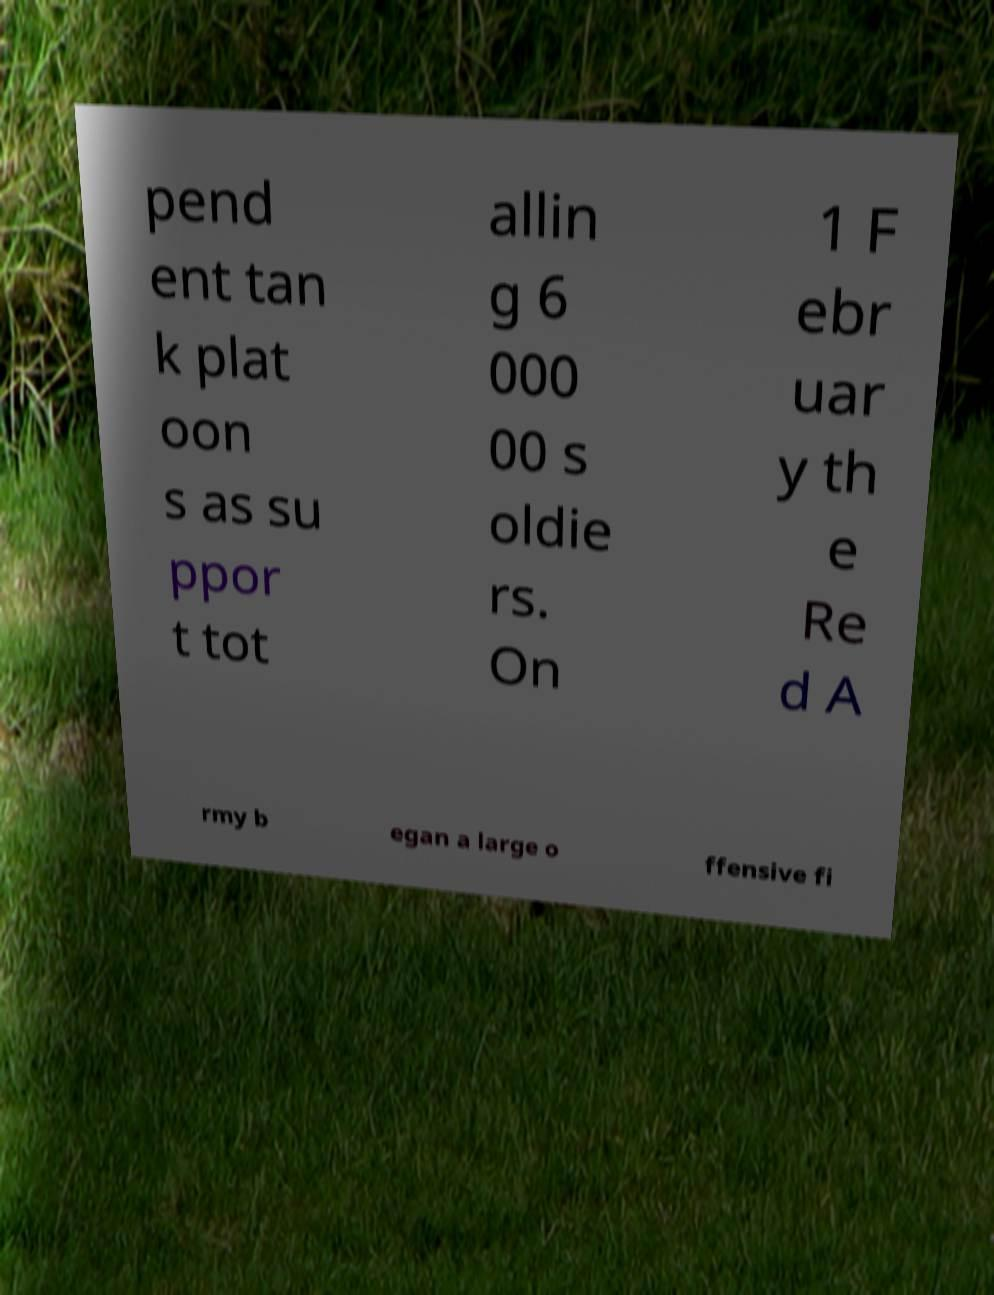For documentation purposes, I need the text within this image transcribed. Could you provide that? pend ent tan k plat oon s as su ppor t tot allin g 6 000 00 s oldie rs. On 1 F ebr uar y th e Re d A rmy b egan a large o ffensive fi 